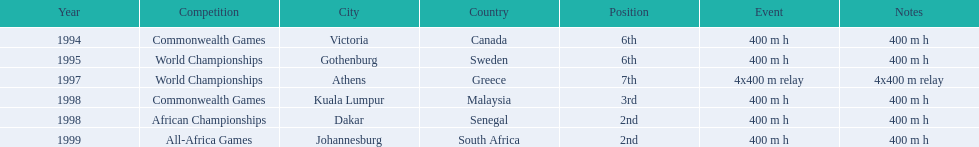What is the last competition on the chart? All-Africa Games. 